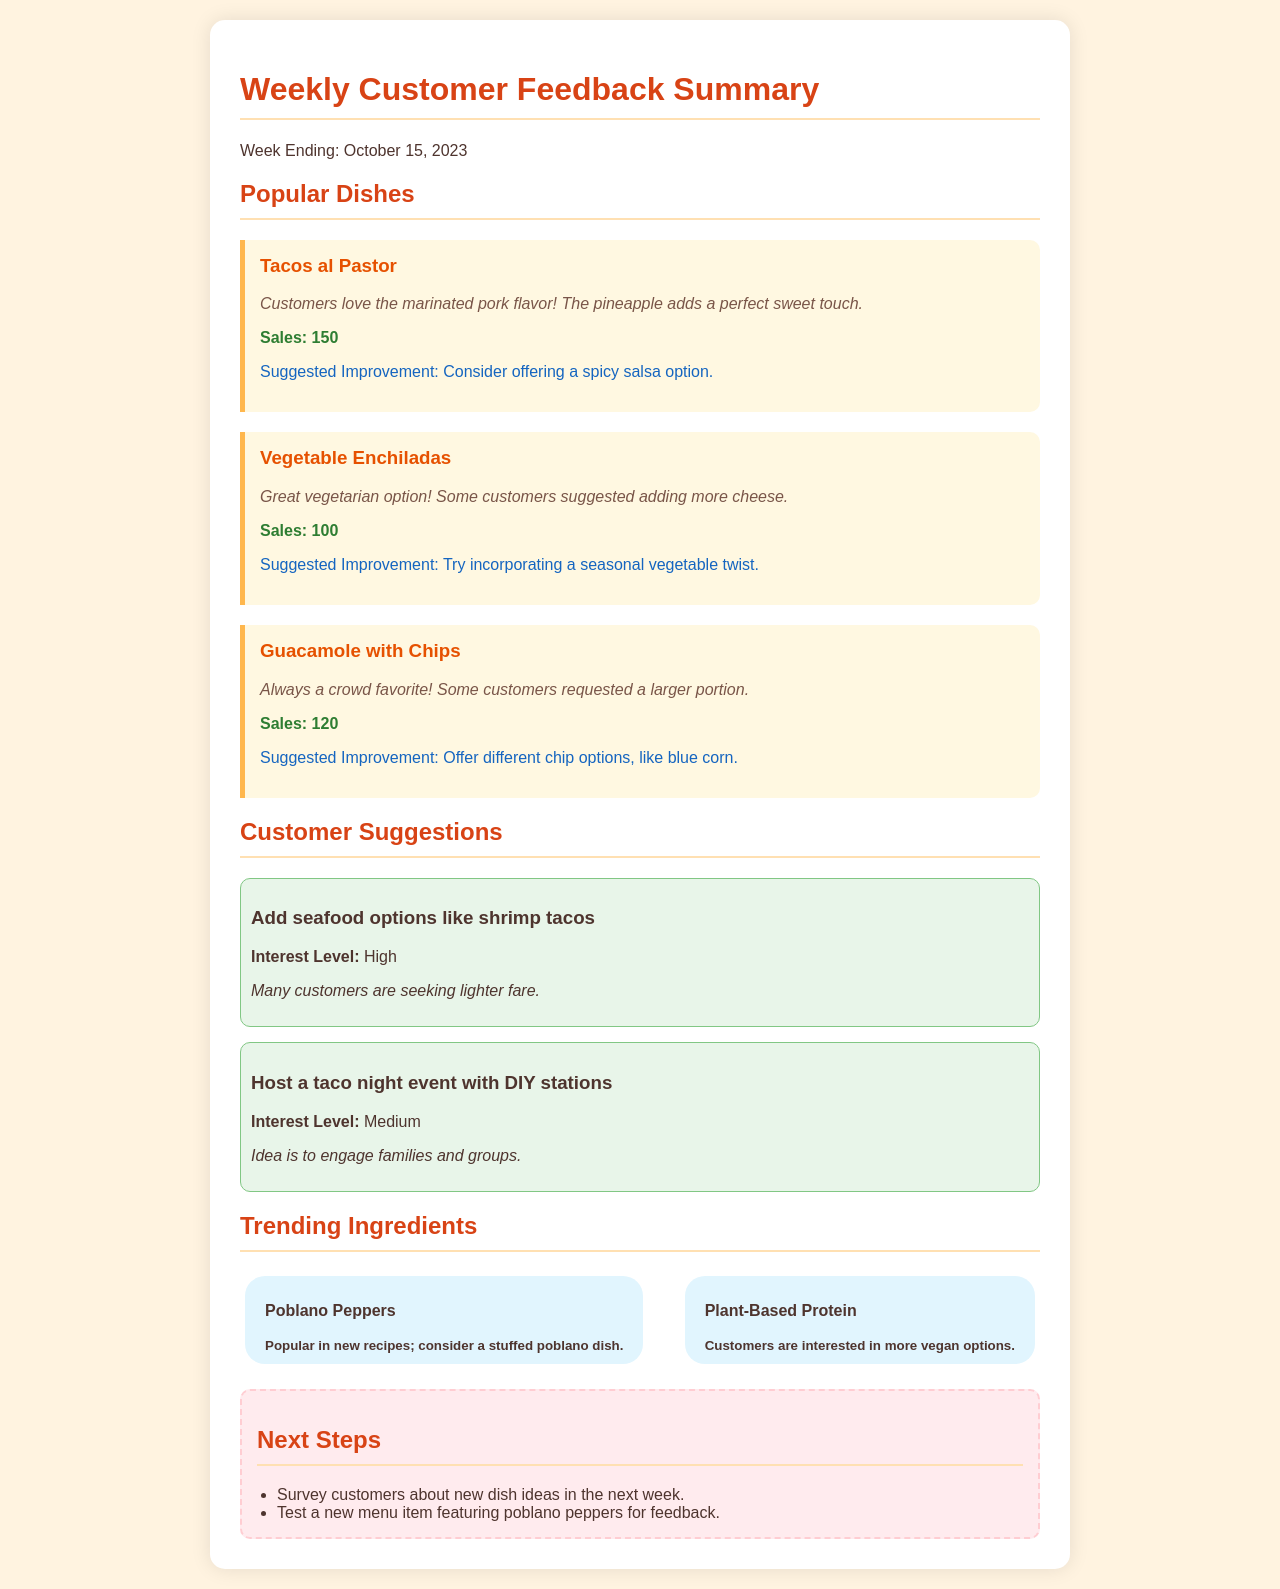What is the week ending date of the report? The report details the feedback for the week ending October 15, 2023.
Answer: October 15, 2023 How many Tacos al Pastor were sold? The document states that 150 Tacos al Pastor were sold during the week.
Answer: 150 What was a suggested improvement for the Vegetable Enchiladas? Customers suggested adding more cheese to the Vegetable Enchiladas.
Answer: More cheese Which dish had the highest sales? Tacos al Pastor had the highest sales compared to the other dishes listed.
Answer: Tacos al Pastor What type of event is suggested to engage families? The document suggests hosting a taco night event with DIY stations to engage families.
Answer: Taco night event Which trending ingredient is mentioned in relation to new recipes? Poblano Peppers are identified as a trending ingredient popular in new recipes.
Answer: Poblano Peppers What feedback was given about Guacamole with Chips? Customers requested a larger portion of Guacamole with Chips.
Answer: Larger portion What is the interest level for adding seafood options like shrimp tacos? The interest level for adding seafood options like shrimp tacos is described as high.
Answer: High What is one next step mentioned in the document? The document suggests surveying customers about new dish ideas as a next step.
Answer: Survey customers 